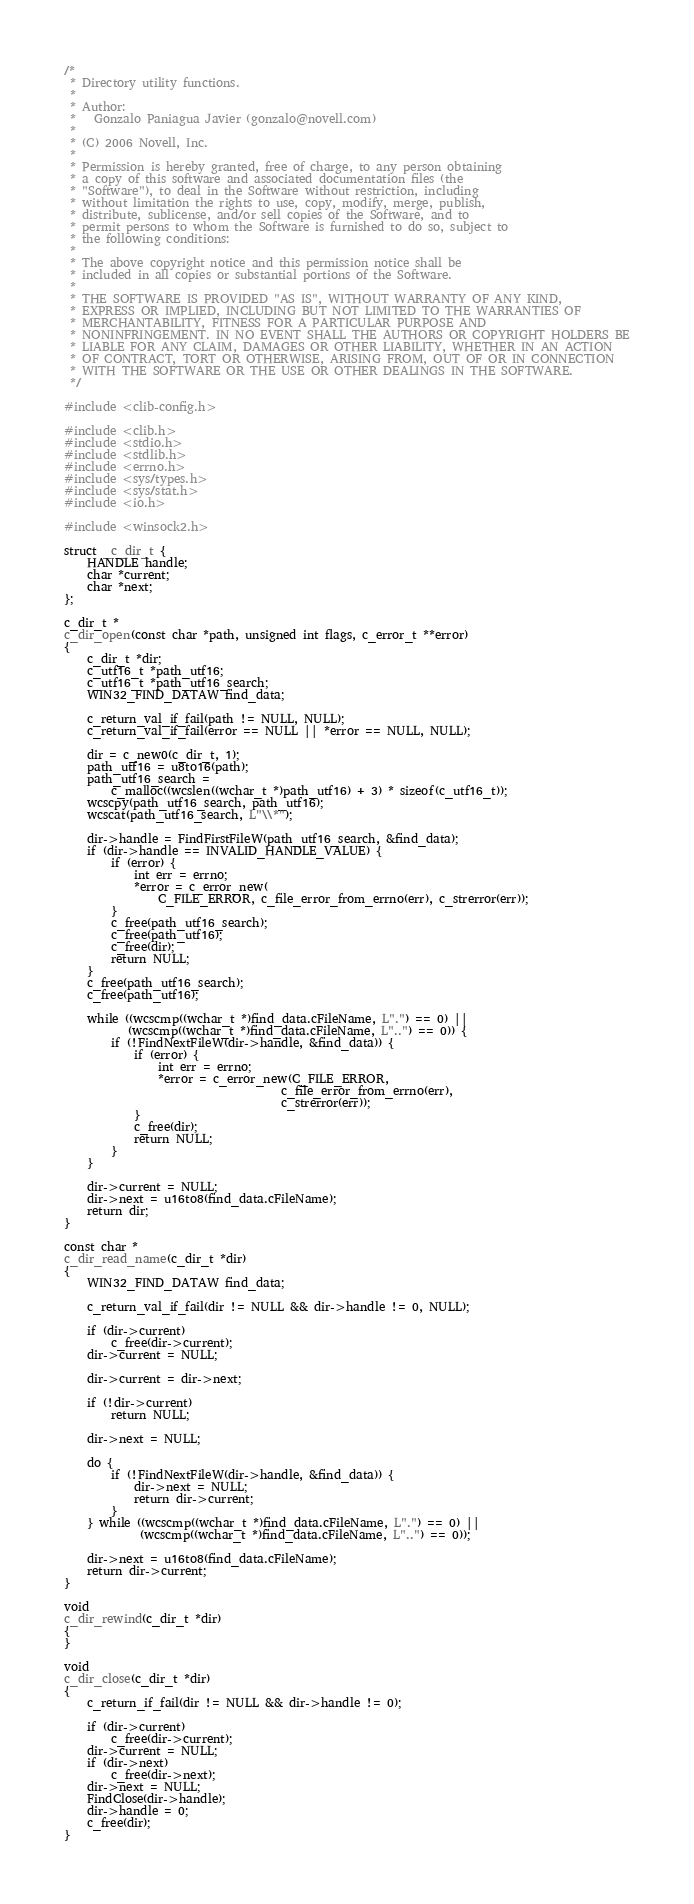<code> <loc_0><loc_0><loc_500><loc_500><_C_>/*
 * Directory utility functions.
 *
 * Author:
 *   Gonzalo Paniagua Javier (gonzalo@novell.com)
 *
 * (C) 2006 Novell, Inc.
 *
 * Permission is hereby granted, free of charge, to any person obtaining
 * a copy of this software and associated documentation files (the
 * "Software"), to deal in the Software without restriction, including
 * without limitation the rights to use, copy, modify, merge, publish,
 * distribute, sublicense, and/or sell copies of the Software, and to
 * permit persons to whom the Software is furnished to do so, subject to
 * the following conditions:
 *
 * The above copyright notice and this permission notice shall be
 * included in all copies or substantial portions of the Software.
 *
 * THE SOFTWARE IS PROVIDED "AS IS", WITHOUT WARRANTY OF ANY KIND,
 * EXPRESS OR IMPLIED, INCLUDING BUT NOT LIMITED TO THE WARRANTIES OF
 * MERCHANTABILITY, FITNESS FOR A PARTICULAR PURPOSE AND
 * NONINFRINGEMENT. IN NO EVENT SHALL THE AUTHORS OR COPYRIGHT HOLDERS BE
 * LIABLE FOR ANY CLAIM, DAMAGES OR OTHER LIABILITY, WHETHER IN AN ACTION
 * OF CONTRACT, TORT OR OTHERWISE, ARISING FROM, OUT OF OR IN CONNECTION
 * WITH THE SOFTWARE OR THE USE OR OTHER DEALINGS IN THE SOFTWARE.
 */

#include <clib-config.h>

#include <clib.h>
#include <stdio.h>
#include <stdlib.h>
#include <errno.h>
#include <sys/types.h>
#include <sys/stat.h>
#include <io.h>

#include <winsock2.h>

struct _c_dir_t {
    HANDLE handle;
    char *current;
    char *next;
};

c_dir_t *
c_dir_open(const char *path, unsigned int flags, c_error_t **error)
{
    c_dir_t *dir;
    c_utf16_t *path_utf16;
    c_utf16_t *path_utf16_search;
    WIN32_FIND_DATAW find_data;

    c_return_val_if_fail(path != NULL, NULL);
    c_return_val_if_fail(error == NULL || *error == NULL, NULL);

    dir = c_new0(c_dir_t, 1);
    path_utf16 = u8to16(path);
    path_utf16_search =
        c_malloc((wcslen((wchar_t *)path_utf16) + 3) * sizeof(c_utf16_t));
    wcscpy(path_utf16_search, path_utf16);
    wcscat(path_utf16_search, L"\\*");

    dir->handle = FindFirstFileW(path_utf16_search, &find_data);
    if (dir->handle == INVALID_HANDLE_VALUE) {
        if (error) {
            int err = errno;
            *error = c_error_new(
                C_FILE_ERROR, c_file_error_from_errno(err), c_strerror(err));
        }
        c_free(path_utf16_search);
        c_free(path_utf16);
        c_free(dir);
        return NULL;
    }
    c_free(path_utf16_search);
    c_free(path_utf16);

    while ((wcscmp((wchar_t *)find_data.cFileName, L".") == 0) ||
           (wcscmp((wchar_t *)find_data.cFileName, L"..") == 0)) {
        if (!FindNextFileW(dir->handle, &find_data)) {
            if (error) {
                int err = errno;
                *error = c_error_new(C_FILE_ERROR,
                                     c_file_error_from_errno(err),
                                     c_strerror(err));
            }
            c_free(dir);
            return NULL;
        }
    }

    dir->current = NULL;
    dir->next = u16to8(find_data.cFileName);
    return dir;
}

const char *
c_dir_read_name(c_dir_t *dir)
{
    WIN32_FIND_DATAW find_data;

    c_return_val_if_fail(dir != NULL && dir->handle != 0, NULL);

    if (dir->current)
        c_free(dir->current);
    dir->current = NULL;

    dir->current = dir->next;

    if (!dir->current)
        return NULL;

    dir->next = NULL;

    do {
        if (!FindNextFileW(dir->handle, &find_data)) {
            dir->next = NULL;
            return dir->current;
        }
    } while ((wcscmp((wchar_t *)find_data.cFileName, L".") == 0) ||
             (wcscmp((wchar_t *)find_data.cFileName, L"..") == 0));

    dir->next = u16to8(find_data.cFileName);
    return dir->current;
}

void
c_dir_rewind(c_dir_t *dir)
{
}

void
c_dir_close(c_dir_t *dir)
{
    c_return_if_fail(dir != NULL && dir->handle != 0);

    if (dir->current)
        c_free(dir->current);
    dir->current = NULL;
    if (dir->next)
        c_free(dir->next);
    dir->next = NULL;
    FindClose(dir->handle);
    dir->handle = 0;
    c_free(dir);
}
</code> 